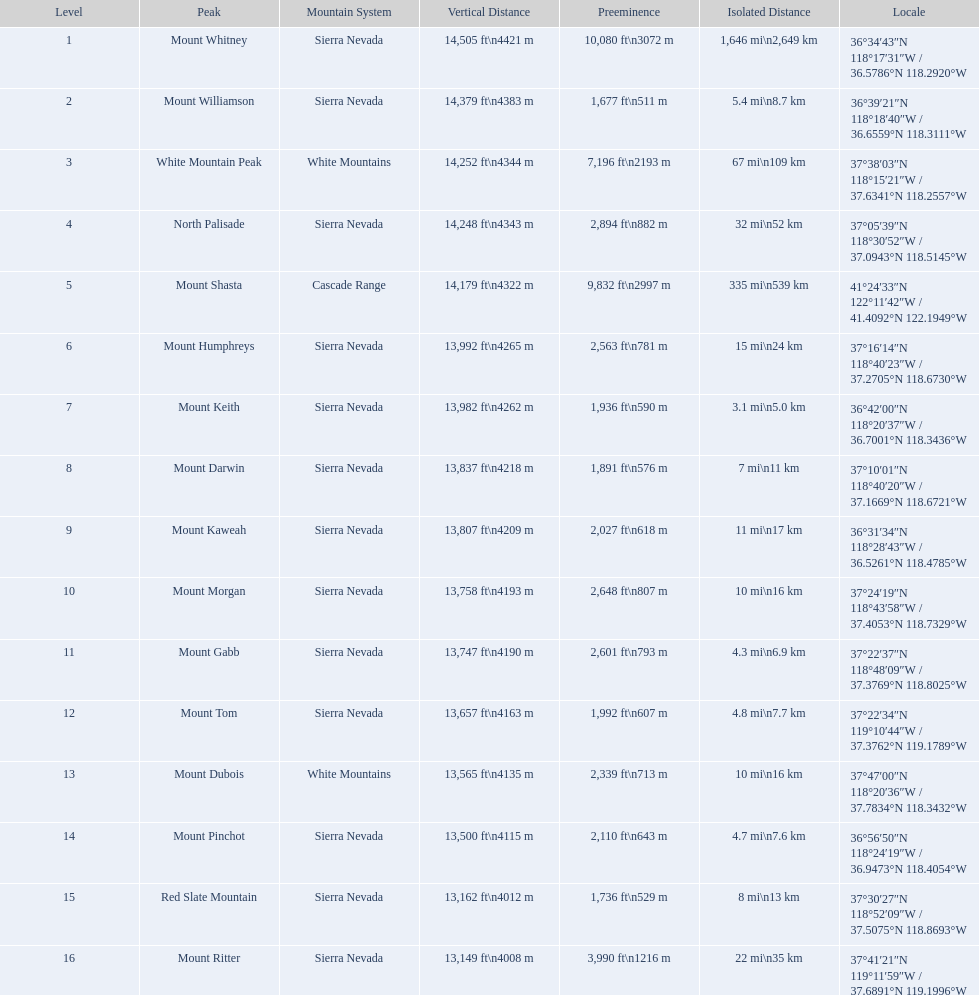Is the peak of mount keith above or below the peak of north palisade? Below. 